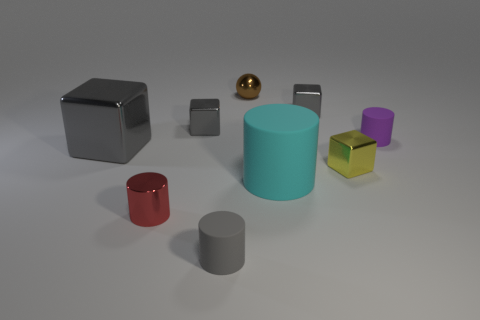How many objects are gray cubes or purple things?
Provide a short and direct response. 4. Are there any purple rubber things of the same shape as the red thing?
Offer a very short reply. Yes. Are there fewer large cyan matte things than small cyan matte cylinders?
Keep it short and to the point. No. Do the big gray shiny object and the yellow metallic object have the same shape?
Offer a terse response. Yes. What number of things are tiny shiny spheres or tiny shiny objects in front of the brown metallic sphere?
Offer a very short reply. 5. What number of rubber objects are there?
Provide a short and direct response. 3. Is there a gray cube of the same size as the metallic cylinder?
Your answer should be compact. Yes. Is the number of small yellow things that are behind the tiny metal cylinder less than the number of tiny red objects?
Make the answer very short. No. Do the brown thing and the cyan matte cylinder have the same size?
Ensure brevity in your answer.  No. What is the size of the cyan object that is the same material as the purple cylinder?
Provide a short and direct response. Large. 